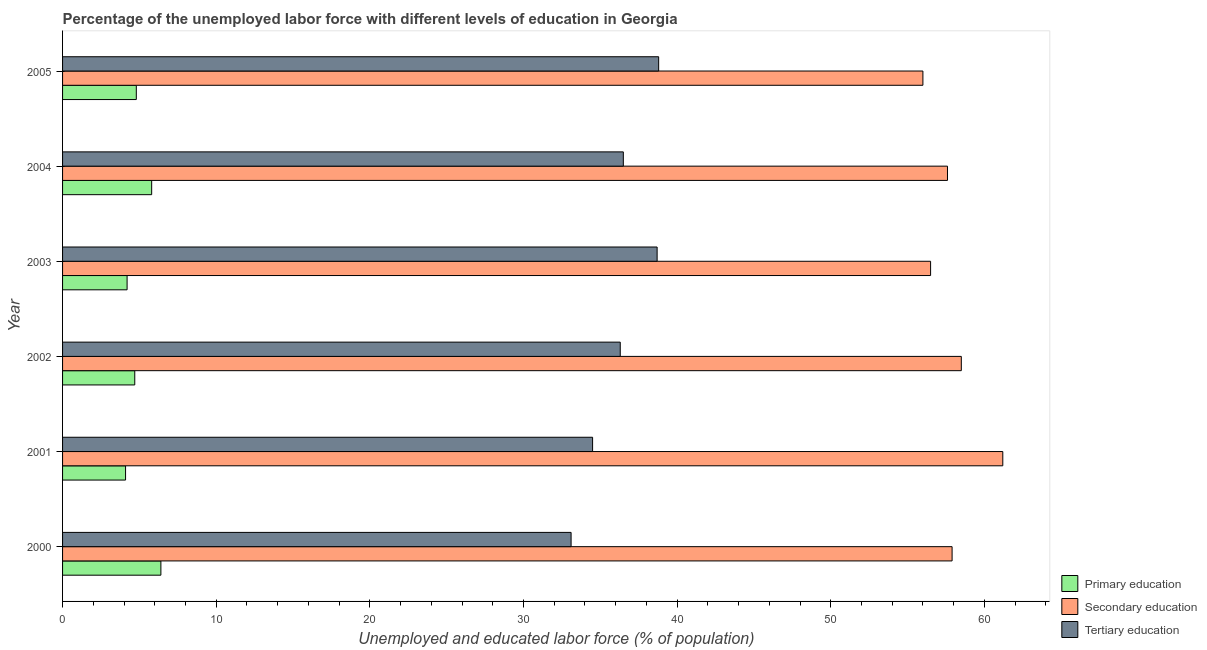Are the number of bars per tick equal to the number of legend labels?
Keep it short and to the point. Yes. How many bars are there on the 2nd tick from the top?
Provide a succinct answer. 3. What is the percentage of labor force who received primary education in 2001?
Your response must be concise. 4.1. Across all years, what is the maximum percentage of labor force who received tertiary education?
Provide a short and direct response. 38.8. Across all years, what is the minimum percentage of labor force who received primary education?
Ensure brevity in your answer.  4.1. In which year was the percentage of labor force who received primary education maximum?
Your answer should be compact. 2000. In which year was the percentage of labor force who received tertiary education minimum?
Ensure brevity in your answer.  2000. What is the total percentage of labor force who received secondary education in the graph?
Give a very brief answer. 347.7. What is the difference between the percentage of labor force who received secondary education in 2003 and the percentage of labor force who received tertiary education in 2000?
Provide a succinct answer. 23.4. What is the average percentage of labor force who received secondary education per year?
Your answer should be compact. 57.95. In the year 2004, what is the difference between the percentage of labor force who received primary education and percentage of labor force who received secondary education?
Give a very brief answer. -51.8. In how many years, is the percentage of labor force who received primary education greater than 50 %?
Give a very brief answer. 0. What is the ratio of the percentage of labor force who received primary education in 2003 to that in 2005?
Provide a succinct answer. 0.88. Is the percentage of labor force who received tertiary education in 2002 less than that in 2005?
Give a very brief answer. Yes. Is the difference between the percentage of labor force who received tertiary education in 2001 and 2005 greater than the difference between the percentage of labor force who received primary education in 2001 and 2005?
Your answer should be very brief. No. In how many years, is the percentage of labor force who received primary education greater than the average percentage of labor force who received primary education taken over all years?
Give a very brief answer. 2. Is the sum of the percentage of labor force who received secondary education in 2004 and 2005 greater than the maximum percentage of labor force who received tertiary education across all years?
Provide a short and direct response. Yes. How many bars are there?
Your answer should be very brief. 18. Are all the bars in the graph horizontal?
Offer a terse response. Yes. How many years are there in the graph?
Keep it short and to the point. 6. What is the difference between two consecutive major ticks on the X-axis?
Offer a terse response. 10. Are the values on the major ticks of X-axis written in scientific E-notation?
Your response must be concise. No. Does the graph contain any zero values?
Offer a very short reply. No. Where does the legend appear in the graph?
Give a very brief answer. Bottom right. How many legend labels are there?
Give a very brief answer. 3. How are the legend labels stacked?
Provide a succinct answer. Vertical. What is the title of the graph?
Provide a short and direct response. Percentage of the unemployed labor force with different levels of education in Georgia. Does "Agricultural raw materials" appear as one of the legend labels in the graph?
Your response must be concise. No. What is the label or title of the X-axis?
Provide a short and direct response. Unemployed and educated labor force (% of population). What is the Unemployed and educated labor force (% of population) of Primary education in 2000?
Offer a terse response. 6.4. What is the Unemployed and educated labor force (% of population) in Secondary education in 2000?
Your answer should be very brief. 57.9. What is the Unemployed and educated labor force (% of population) of Tertiary education in 2000?
Provide a short and direct response. 33.1. What is the Unemployed and educated labor force (% of population) of Primary education in 2001?
Keep it short and to the point. 4.1. What is the Unemployed and educated labor force (% of population) in Secondary education in 2001?
Offer a very short reply. 61.2. What is the Unemployed and educated labor force (% of population) in Tertiary education in 2001?
Keep it short and to the point. 34.5. What is the Unemployed and educated labor force (% of population) in Primary education in 2002?
Offer a terse response. 4.7. What is the Unemployed and educated labor force (% of population) of Secondary education in 2002?
Ensure brevity in your answer.  58.5. What is the Unemployed and educated labor force (% of population) in Tertiary education in 2002?
Provide a short and direct response. 36.3. What is the Unemployed and educated labor force (% of population) of Primary education in 2003?
Your answer should be compact. 4.2. What is the Unemployed and educated labor force (% of population) in Secondary education in 2003?
Your answer should be very brief. 56.5. What is the Unemployed and educated labor force (% of population) in Tertiary education in 2003?
Your answer should be very brief. 38.7. What is the Unemployed and educated labor force (% of population) of Primary education in 2004?
Provide a succinct answer. 5.8. What is the Unemployed and educated labor force (% of population) of Secondary education in 2004?
Your response must be concise. 57.6. What is the Unemployed and educated labor force (% of population) in Tertiary education in 2004?
Offer a terse response. 36.5. What is the Unemployed and educated labor force (% of population) of Primary education in 2005?
Provide a short and direct response. 4.8. What is the Unemployed and educated labor force (% of population) in Tertiary education in 2005?
Keep it short and to the point. 38.8. Across all years, what is the maximum Unemployed and educated labor force (% of population) of Primary education?
Keep it short and to the point. 6.4. Across all years, what is the maximum Unemployed and educated labor force (% of population) in Secondary education?
Your answer should be very brief. 61.2. Across all years, what is the maximum Unemployed and educated labor force (% of population) of Tertiary education?
Give a very brief answer. 38.8. Across all years, what is the minimum Unemployed and educated labor force (% of population) in Primary education?
Make the answer very short. 4.1. Across all years, what is the minimum Unemployed and educated labor force (% of population) of Secondary education?
Provide a succinct answer. 56. Across all years, what is the minimum Unemployed and educated labor force (% of population) in Tertiary education?
Offer a very short reply. 33.1. What is the total Unemployed and educated labor force (% of population) in Secondary education in the graph?
Ensure brevity in your answer.  347.7. What is the total Unemployed and educated labor force (% of population) in Tertiary education in the graph?
Offer a terse response. 217.9. What is the difference between the Unemployed and educated labor force (% of population) in Primary education in 2000 and that in 2001?
Keep it short and to the point. 2.3. What is the difference between the Unemployed and educated labor force (% of population) in Primary education in 2000 and that in 2002?
Offer a very short reply. 1.7. What is the difference between the Unemployed and educated labor force (% of population) of Secondary education in 2000 and that in 2003?
Make the answer very short. 1.4. What is the difference between the Unemployed and educated labor force (% of population) in Tertiary education in 2000 and that in 2003?
Your answer should be compact. -5.6. What is the difference between the Unemployed and educated labor force (% of population) of Secondary education in 2000 and that in 2004?
Provide a succinct answer. 0.3. What is the difference between the Unemployed and educated labor force (% of population) of Primary education in 2000 and that in 2005?
Your answer should be compact. 1.6. What is the difference between the Unemployed and educated labor force (% of population) of Secondary education in 2000 and that in 2005?
Offer a very short reply. 1.9. What is the difference between the Unemployed and educated labor force (% of population) of Tertiary education in 2000 and that in 2005?
Keep it short and to the point. -5.7. What is the difference between the Unemployed and educated labor force (% of population) of Primary education in 2001 and that in 2002?
Offer a very short reply. -0.6. What is the difference between the Unemployed and educated labor force (% of population) of Secondary education in 2001 and that in 2002?
Give a very brief answer. 2.7. What is the difference between the Unemployed and educated labor force (% of population) in Primary education in 2001 and that in 2004?
Keep it short and to the point. -1.7. What is the difference between the Unemployed and educated labor force (% of population) of Primary education in 2001 and that in 2005?
Your answer should be compact. -0.7. What is the difference between the Unemployed and educated labor force (% of population) of Secondary education in 2002 and that in 2003?
Give a very brief answer. 2. What is the difference between the Unemployed and educated labor force (% of population) in Secondary education in 2002 and that in 2004?
Provide a short and direct response. 0.9. What is the difference between the Unemployed and educated labor force (% of population) of Tertiary education in 2002 and that in 2004?
Make the answer very short. -0.2. What is the difference between the Unemployed and educated labor force (% of population) in Primary education in 2002 and that in 2005?
Provide a short and direct response. -0.1. What is the difference between the Unemployed and educated labor force (% of population) in Tertiary education in 2002 and that in 2005?
Your response must be concise. -2.5. What is the difference between the Unemployed and educated labor force (% of population) in Primary education in 2004 and that in 2005?
Provide a short and direct response. 1. What is the difference between the Unemployed and educated labor force (% of population) in Tertiary education in 2004 and that in 2005?
Ensure brevity in your answer.  -2.3. What is the difference between the Unemployed and educated labor force (% of population) of Primary education in 2000 and the Unemployed and educated labor force (% of population) of Secondary education in 2001?
Your answer should be compact. -54.8. What is the difference between the Unemployed and educated labor force (% of population) in Primary education in 2000 and the Unemployed and educated labor force (% of population) in Tertiary education in 2001?
Keep it short and to the point. -28.1. What is the difference between the Unemployed and educated labor force (% of population) of Secondary education in 2000 and the Unemployed and educated labor force (% of population) of Tertiary education in 2001?
Provide a succinct answer. 23.4. What is the difference between the Unemployed and educated labor force (% of population) of Primary education in 2000 and the Unemployed and educated labor force (% of population) of Secondary education in 2002?
Ensure brevity in your answer.  -52.1. What is the difference between the Unemployed and educated labor force (% of population) of Primary education in 2000 and the Unemployed and educated labor force (% of population) of Tertiary education in 2002?
Your answer should be very brief. -29.9. What is the difference between the Unemployed and educated labor force (% of population) of Secondary education in 2000 and the Unemployed and educated labor force (% of population) of Tertiary education in 2002?
Give a very brief answer. 21.6. What is the difference between the Unemployed and educated labor force (% of population) in Primary education in 2000 and the Unemployed and educated labor force (% of population) in Secondary education in 2003?
Make the answer very short. -50.1. What is the difference between the Unemployed and educated labor force (% of population) of Primary education in 2000 and the Unemployed and educated labor force (% of population) of Tertiary education in 2003?
Keep it short and to the point. -32.3. What is the difference between the Unemployed and educated labor force (% of population) of Secondary education in 2000 and the Unemployed and educated labor force (% of population) of Tertiary education in 2003?
Ensure brevity in your answer.  19.2. What is the difference between the Unemployed and educated labor force (% of population) of Primary education in 2000 and the Unemployed and educated labor force (% of population) of Secondary education in 2004?
Your answer should be very brief. -51.2. What is the difference between the Unemployed and educated labor force (% of population) of Primary education in 2000 and the Unemployed and educated labor force (% of population) of Tertiary education in 2004?
Give a very brief answer. -30.1. What is the difference between the Unemployed and educated labor force (% of population) in Secondary education in 2000 and the Unemployed and educated labor force (% of population) in Tertiary education in 2004?
Provide a succinct answer. 21.4. What is the difference between the Unemployed and educated labor force (% of population) in Primary education in 2000 and the Unemployed and educated labor force (% of population) in Secondary education in 2005?
Offer a very short reply. -49.6. What is the difference between the Unemployed and educated labor force (% of population) in Primary education in 2000 and the Unemployed and educated labor force (% of population) in Tertiary education in 2005?
Your answer should be compact. -32.4. What is the difference between the Unemployed and educated labor force (% of population) in Secondary education in 2000 and the Unemployed and educated labor force (% of population) in Tertiary education in 2005?
Provide a succinct answer. 19.1. What is the difference between the Unemployed and educated labor force (% of population) in Primary education in 2001 and the Unemployed and educated labor force (% of population) in Secondary education in 2002?
Offer a very short reply. -54.4. What is the difference between the Unemployed and educated labor force (% of population) in Primary education in 2001 and the Unemployed and educated labor force (% of population) in Tertiary education in 2002?
Your response must be concise. -32.2. What is the difference between the Unemployed and educated labor force (% of population) in Secondary education in 2001 and the Unemployed and educated labor force (% of population) in Tertiary education in 2002?
Provide a short and direct response. 24.9. What is the difference between the Unemployed and educated labor force (% of population) of Primary education in 2001 and the Unemployed and educated labor force (% of population) of Secondary education in 2003?
Give a very brief answer. -52.4. What is the difference between the Unemployed and educated labor force (% of population) in Primary education in 2001 and the Unemployed and educated labor force (% of population) in Tertiary education in 2003?
Give a very brief answer. -34.6. What is the difference between the Unemployed and educated labor force (% of population) in Primary education in 2001 and the Unemployed and educated labor force (% of population) in Secondary education in 2004?
Give a very brief answer. -53.5. What is the difference between the Unemployed and educated labor force (% of population) of Primary education in 2001 and the Unemployed and educated labor force (% of population) of Tertiary education in 2004?
Ensure brevity in your answer.  -32.4. What is the difference between the Unemployed and educated labor force (% of population) in Secondary education in 2001 and the Unemployed and educated labor force (% of population) in Tertiary education in 2004?
Offer a terse response. 24.7. What is the difference between the Unemployed and educated labor force (% of population) in Primary education in 2001 and the Unemployed and educated labor force (% of population) in Secondary education in 2005?
Provide a succinct answer. -51.9. What is the difference between the Unemployed and educated labor force (% of population) in Primary education in 2001 and the Unemployed and educated labor force (% of population) in Tertiary education in 2005?
Offer a very short reply. -34.7. What is the difference between the Unemployed and educated labor force (% of population) of Secondary education in 2001 and the Unemployed and educated labor force (% of population) of Tertiary education in 2005?
Your answer should be very brief. 22.4. What is the difference between the Unemployed and educated labor force (% of population) in Primary education in 2002 and the Unemployed and educated labor force (% of population) in Secondary education in 2003?
Your answer should be very brief. -51.8. What is the difference between the Unemployed and educated labor force (% of population) in Primary education in 2002 and the Unemployed and educated labor force (% of population) in Tertiary education in 2003?
Provide a succinct answer. -34. What is the difference between the Unemployed and educated labor force (% of population) of Secondary education in 2002 and the Unemployed and educated labor force (% of population) of Tertiary education in 2003?
Keep it short and to the point. 19.8. What is the difference between the Unemployed and educated labor force (% of population) in Primary education in 2002 and the Unemployed and educated labor force (% of population) in Secondary education in 2004?
Offer a very short reply. -52.9. What is the difference between the Unemployed and educated labor force (% of population) in Primary education in 2002 and the Unemployed and educated labor force (% of population) in Tertiary education in 2004?
Ensure brevity in your answer.  -31.8. What is the difference between the Unemployed and educated labor force (% of population) of Primary education in 2002 and the Unemployed and educated labor force (% of population) of Secondary education in 2005?
Ensure brevity in your answer.  -51.3. What is the difference between the Unemployed and educated labor force (% of population) of Primary education in 2002 and the Unemployed and educated labor force (% of population) of Tertiary education in 2005?
Offer a very short reply. -34.1. What is the difference between the Unemployed and educated labor force (% of population) in Primary education in 2003 and the Unemployed and educated labor force (% of population) in Secondary education in 2004?
Offer a terse response. -53.4. What is the difference between the Unemployed and educated labor force (% of population) of Primary education in 2003 and the Unemployed and educated labor force (% of population) of Tertiary education in 2004?
Offer a terse response. -32.3. What is the difference between the Unemployed and educated labor force (% of population) of Secondary education in 2003 and the Unemployed and educated labor force (% of population) of Tertiary education in 2004?
Ensure brevity in your answer.  20. What is the difference between the Unemployed and educated labor force (% of population) of Primary education in 2003 and the Unemployed and educated labor force (% of population) of Secondary education in 2005?
Keep it short and to the point. -51.8. What is the difference between the Unemployed and educated labor force (% of population) in Primary education in 2003 and the Unemployed and educated labor force (% of population) in Tertiary education in 2005?
Ensure brevity in your answer.  -34.6. What is the difference between the Unemployed and educated labor force (% of population) of Secondary education in 2003 and the Unemployed and educated labor force (% of population) of Tertiary education in 2005?
Your response must be concise. 17.7. What is the difference between the Unemployed and educated labor force (% of population) of Primary education in 2004 and the Unemployed and educated labor force (% of population) of Secondary education in 2005?
Your answer should be compact. -50.2. What is the difference between the Unemployed and educated labor force (% of population) in Primary education in 2004 and the Unemployed and educated labor force (% of population) in Tertiary education in 2005?
Keep it short and to the point. -33. What is the difference between the Unemployed and educated labor force (% of population) of Secondary education in 2004 and the Unemployed and educated labor force (% of population) of Tertiary education in 2005?
Provide a succinct answer. 18.8. What is the average Unemployed and educated labor force (% of population) in Primary education per year?
Provide a short and direct response. 5. What is the average Unemployed and educated labor force (% of population) in Secondary education per year?
Ensure brevity in your answer.  57.95. What is the average Unemployed and educated labor force (% of population) in Tertiary education per year?
Your response must be concise. 36.32. In the year 2000, what is the difference between the Unemployed and educated labor force (% of population) in Primary education and Unemployed and educated labor force (% of population) in Secondary education?
Your response must be concise. -51.5. In the year 2000, what is the difference between the Unemployed and educated labor force (% of population) in Primary education and Unemployed and educated labor force (% of population) in Tertiary education?
Make the answer very short. -26.7. In the year 2000, what is the difference between the Unemployed and educated labor force (% of population) of Secondary education and Unemployed and educated labor force (% of population) of Tertiary education?
Ensure brevity in your answer.  24.8. In the year 2001, what is the difference between the Unemployed and educated labor force (% of population) of Primary education and Unemployed and educated labor force (% of population) of Secondary education?
Give a very brief answer. -57.1. In the year 2001, what is the difference between the Unemployed and educated labor force (% of population) of Primary education and Unemployed and educated labor force (% of population) of Tertiary education?
Give a very brief answer. -30.4. In the year 2001, what is the difference between the Unemployed and educated labor force (% of population) of Secondary education and Unemployed and educated labor force (% of population) of Tertiary education?
Make the answer very short. 26.7. In the year 2002, what is the difference between the Unemployed and educated labor force (% of population) of Primary education and Unemployed and educated labor force (% of population) of Secondary education?
Offer a very short reply. -53.8. In the year 2002, what is the difference between the Unemployed and educated labor force (% of population) of Primary education and Unemployed and educated labor force (% of population) of Tertiary education?
Provide a succinct answer. -31.6. In the year 2003, what is the difference between the Unemployed and educated labor force (% of population) of Primary education and Unemployed and educated labor force (% of population) of Secondary education?
Provide a short and direct response. -52.3. In the year 2003, what is the difference between the Unemployed and educated labor force (% of population) in Primary education and Unemployed and educated labor force (% of population) in Tertiary education?
Your answer should be very brief. -34.5. In the year 2003, what is the difference between the Unemployed and educated labor force (% of population) of Secondary education and Unemployed and educated labor force (% of population) of Tertiary education?
Keep it short and to the point. 17.8. In the year 2004, what is the difference between the Unemployed and educated labor force (% of population) of Primary education and Unemployed and educated labor force (% of population) of Secondary education?
Keep it short and to the point. -51.8. In the year 2004, what is the difference between the Unemployed and educated labor force (% of population) of Primary education and Unemployed and educated labor force (% of population) of Tertiary education?
Make the answer very short. -30.7. In the year 2004, what is the difference between the Unemployed and educated labor force (% of population) of Secondary education and Unemployed and educated labor force (% of population) of Tertiary education?
Give a very brief answer. 21.1. In the year 2005, what is the difference between the Unemployed and educated labor force (% of population) of Primary education and Unemployed and educated labor force (% of population) of Secondary education?
Offer a terse response. -51.2. In the year 2005, what is the difference between the Unemployed and educated labor force (% of population) in Primary education and Unemployed and educated labor force (% of population) in Tertiary education?
Keep it short and to the point. -34. What is the ratio of the Unemployed and educated labor force (% of population) of Primary education in 2000 to that in 2001?
Ensure brevity in your answer.  1.56. What is the ratio of the Unemployed and educated labor force (% of population) in Secondary education in 2000 to that in 2001?
Make the answer very short. 0.95. What is the ratio of the Unemployed and educated labor force (% of population) of Tertiary education in 2000 to that in 2001?
Provide a succinct answer. 0.96. What is the ratio of the Unemployed and educated labor force (% of population) of Primary education in 2000 to that in 2002?
Give a very brief answer. 1.36. What is the ratio of the Unemployed and educated labor force (% of population) in Tertiary education in 2000 to that in 2002?
Provide a short and direct response. 0.91. What is the ratio of the Unemployed and educated labor force (% of population) of Primary education in 2000 to that in 2003?
Your answer should be compact. 1.52. What is the ratio of the Unemployed and educated labor force (% of population) of Secondary education in 2000 to that in 2003?
Offer a very short reply. 1.02. What is the ratio of the Unemployed and educated labor force (% of population) in Tertiary education in 2000 to that in 2003?
Give a very brief answer. 0.86. What is the ratio of the Unemployed and educated labor force (% of population) in Primary education in 2000 to that in 2004?
Give a very brief answer. 1.1. What is the ratio of the Unemployed and educated labor force (% of population) of Secondary education in 2000 to that in 2004?
Ensure brevity in your answer.  1.01. What is the ratio of the Unemployed and educated labor force (% of population) in Tertiary education in 2000 to that in 2004?
Offer a very short reply. 0.91. What is the ratio of the Unemployed and educated labor force (% of population) of Secondary education in 2000 to that in 2005?
Provide a short and direct response. 1.03. What is the ratio of the Unemployed and educated labor force (% of population) of Tertiary education in 2000 to that in 2005?
Your answer should be very brief. 0.85. What is the ratio of the Unemployed and educated labor force (% of population) of Primary education in 2001 to that in 2002?
Ensure brevity in your answer.  0.87. What is the ratio of the Unemployed and educated labor force (% of population) in Secondary education in 2001 to that in 2002?
Your answer should be compact. 1.05. What is the ratio of the Unemployed and educated labor force (% of population) of Tertiary education in 2001 to that in 2002?
Provide a succinct answer. 0.95. What is the ratio of the Unemployed and educated labor force (% of population) of Primary education in 2001 to that in 2003?
Offer a terse response. 0.98. What is the ratio of the Unemployed and educated labor force (% of population) of Secondary education in 2001 to that in 2003?
Offer a terse response. 1.08. What is the ratio of the Unemployed and educated labor force (% of population) in Tertiary education in 2001 to that in 2003?
Make the answer very short. 0.89. What is the ratio of the Unemployed and educated labor force (% of population) in Primary education in 2001 to that in 2004?
Provide a succinct answer. 0.71. What is the ratio of the Unemployed and educated labor force (% of population) of Tertiary education in 2001 to that in 2004?
Offer a very short reply. 0.95. What is the ratio of the Unemployed and educated labor force (% of population) in Primary education in 2001 to that in 2005?
Provide a succinct answer. 0.85. What is the ratio of the Unemployed and educated labor force (% of population) of Secondary education in 2001 to that in 2005?
Your response must be concise. 1.09. What is the ratio of the Unemployed and educated labor force (% of population) of Tertiary education in 2001 to that in 2005?
Your response must be concise. 0.89. What is the ratio of the Unemployed and educated labor force (% of population) in Primary education in 2002 to that in 2003?
Provide a succinct answer. 1.12. What is the ratio of the Unemployed and educated labor force (% of population) of Secondary education in 2002 to that in 2003?
Provide a short and direct response. 1.04. What is the ratio of the Unemployed and educated labor force (% of population) of Tertiary education in 2002 to that in 2003?
Provide a short and direct response. 0.94. What is the ratio of the Unemployed and educated labor force (% of population) of Primary education in 2002 to that in 2004?
Your answer should be very brief. 0.81. What is the ratio of the Unemployed and educated labor force (% of population) of Secondary education in 2002 to that in 2004?
Keep it short and to the point. 1.02. What is the ratio of the Unemployed and educated labor force (% of population) of Primary education in 2002 to that in 2005?
Keep it short and to the point. 0.98. What is the ratio of the Unemployed and educated labor force (% of population) in Secondary education in 2002 to that in 2005?
Provide a short and direct response. 1.04. What is the ratio of the Unemployed and educated labor force (% of population) of Tertiary education in 2002 to that in 2005?
Offer a very short reply. 0.94. What is the ratio of the Unemployed and educated labor force (% of population) of Primary education in 2003 to that in 2004?
Your response must be concise. 0.72. What is the ratio of the Unemployed and educated labor force (% of population) in Secondary education in 2003 to that in 2004?
Provide a succinct answer. 0.98. What is the ratio of the Unemployed and educated labor force (% of population) in Tertiary education in 2003 to that in 2004?
Your answer should be very brief. 1.06. What is the ratio of the Unemployed and educated labor force (% of population) in Primary education in 2003 to that in 2005?
Make the answer very short. 0.88. What is the ratio of the Unemployed and educated labor force (% of population) in Secondary education in 2003 to that in 2005?
Provide a succinct answer. 1.01. What is the ratio of the Unemployed and educated labor force (% of population) in Primary education in 2004 to that in 2005?
Provide a succinct answer. 1.21. What is the ratio of the Unemployed and educated labor force (% of population) in Secondary education in 2004 to that in 2005?
Offer a terse response. 1.03. What is the ratio of the Unemployed and educated labor force (% of population) of Tertiary education in 2004 to that in 2005?
Make the answer very short. 0.94. What is the difference between the highest and the second highest Unemployed and educated labor force (% of population) in Primary education?
Your response must be concise. 0.6. What is the difference between the highest and the lowest Unemployed and educated labor force (% of population) of Primary education?
Keep it short and to the point. 2.3. What is the difference between the highest and the lowest Unemployed and educated labor force (% of population) in Secondary education?
Offer a terse response. 5.2. What is the difference between the highest and the lowest Unemployed and educated labor force (% of population) in Tertiary education?
Your answer should be compact. 5.7. 